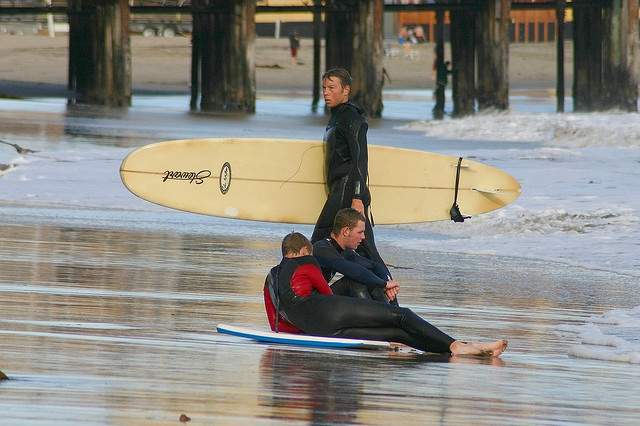Describe the objects in this image and their specific colors. I can see surfboard in darkgreen and tan tones, people in darkgreen, black, maroon, and brown tones, surfboard in darkgreen, beige, blue, darkgray, and navy tones, people in darkgreen, black, and gray tones, and people in darkgreen, black, and gray tones in this image. 